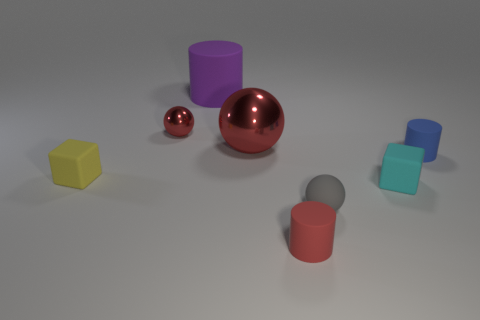How many other objects are the same material as the tiny blue cylinder?
Your response must be concise. 5. What number of small objects are purple things or cubes?
Offer a terse response. 2. Is the number of shiny spheres on the left side of the large sphere the same as the number of big gray metallic cylinders?
Make the answer very short. No. There is a rubber cylinder on the left side of the large sphere; is there a blue object that is to the left of it?
Give a very brief answer. No. How many other things are the same color as the small metal object?
Give a very brief answer. 2. What color is the large rubber cylinder?
Provide a succinct answer. Purple. How big is the cylinder that is on the right side of the large purple object and on the left side of the small cyan object?
Your answer should be compact. Small. What number of things are either small metal spheres that are left of the small blue rubber cylinder or blocks?
Ensure brevity in your answer.  3. There is a tiny red object that is made of the same material as the purple thing; what is its shape?
Offer a very short reply. Cylinder. The big red metallic object is what shape?
Provide a succinct answer. Sphere. 